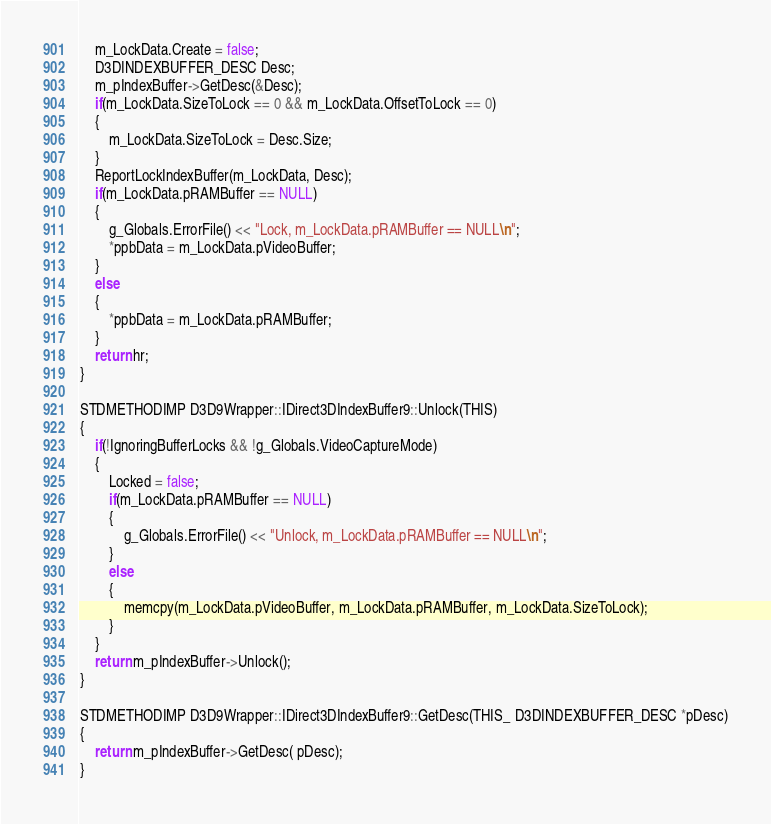<code> <loc_0><loc_0><loc_500><loc_500><_C_>	m_LockData.Create = false;
	D3DINDEXBUFFER_DESC Desc;
	m_pIndexBuffer->GetDesc(&Desc);
	if(m_LockData.SizeToLock == 0 && m_LockData.OffsetToLock == 0)
	{
		m_LockData.SizeToLock = Desc.Size;
	}
	ReportLockIndexBuffer(m_LockData, Desc);
	if(m_LockData.pRAMBuffer == NULL)
	{
		g_Globals.ErrorFile() << "Lock, m_LockData.pRAMBuffer == NULL\n";
		*ppbData = m_LockData.pVideoBuffer;
	}
	else
	{
		*ppbData = m_LockData.pRAMBuffer;
	}
	return hr;
}

STDMETHODIMP D3D9Wrapper::IDirect3DIndexBuffer9::Unlock(THIS)
{
	if(!IgnoringBufferLocks && !g_Globals.VideoCaptureMode)
	{
		Locked = false;
		if(m_LockData.pRAMBuffer == NULL)
		{
			g_Globals.ErrorFile() << "Unlock, m_LockData.pRAMBuffer == NULL\n";
		}
		else
		{
			memcpy(m_LockData.pVideoBuffer, m_LockData.pRAMBuffer, m_LockData.SizeToLock);
		}
	}
	return m_pIndexBuffer->Unlock();
}

STDMETHODIMP D3D9Wrapper::IDirect3DIndexBuffer9::GetDesc(THIS_ D3DINDEXBUFFER_DESC *pDesc)
{
	return m_pIndexBuffer->GetDesc( pDesc);
}

</code> 